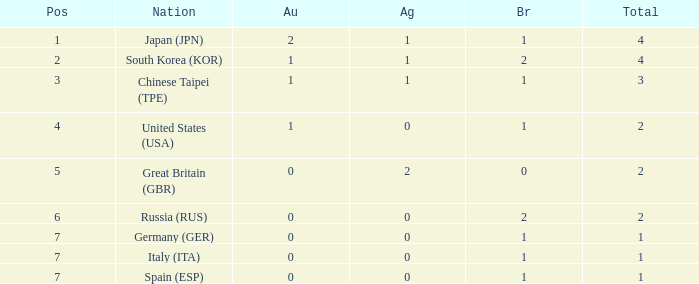What is the smallest number of gold of a country of rank 6, with 2 bronzes? None. 